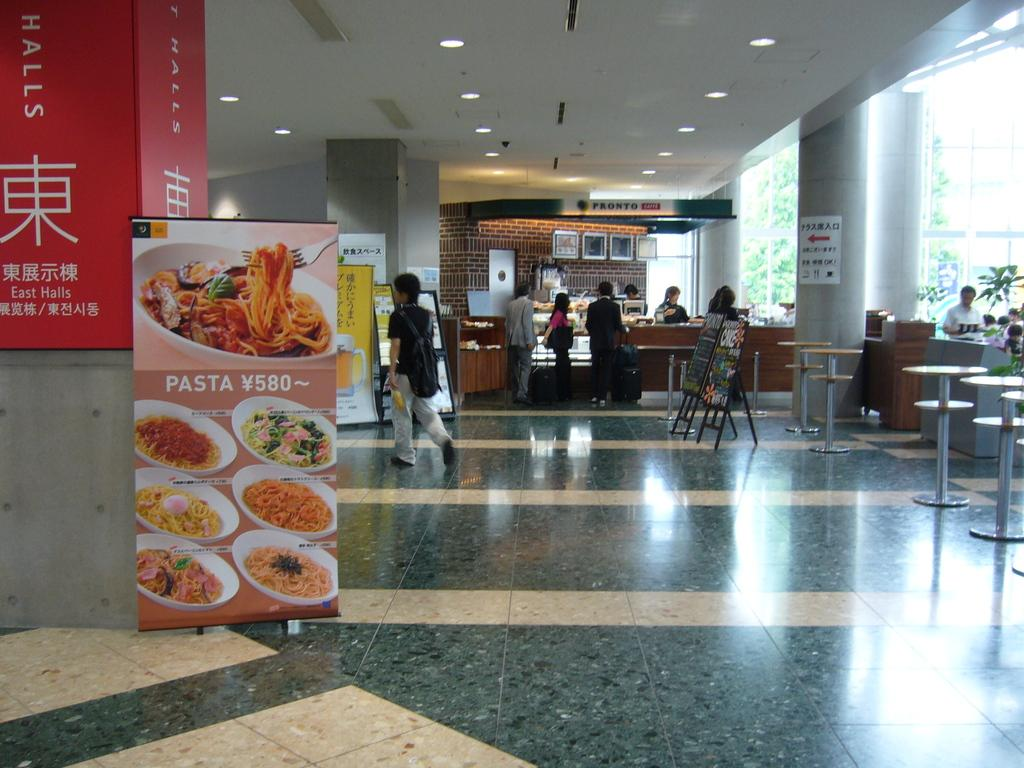How many people can be seen in the image? There are persons in the image, but the exact number cannot be determined from the provided facts. What type of surface is visible in the image? The image shows a floor. What type of advertising materials are present in the image? There are hoardings and a poster in the image. What type of furniture is present in the image? Tables are present in the image. What type of structures are visible in the image? Boards and pillars are visible in the image. What type of illumination is present in the image? Lights are present in the image. What type of decorative elements are present in the image? There are frames in the image. What type of background can be seen in the image? A wall is visible in the background of the image. What type of toys are being sold in the image? There is no mention of toys in the image, so it cannot be determined if any are being sold. What type of produce is being displayed in the image? There is no mention of produce in the image, so it cannot be determined if any is being displayed. 